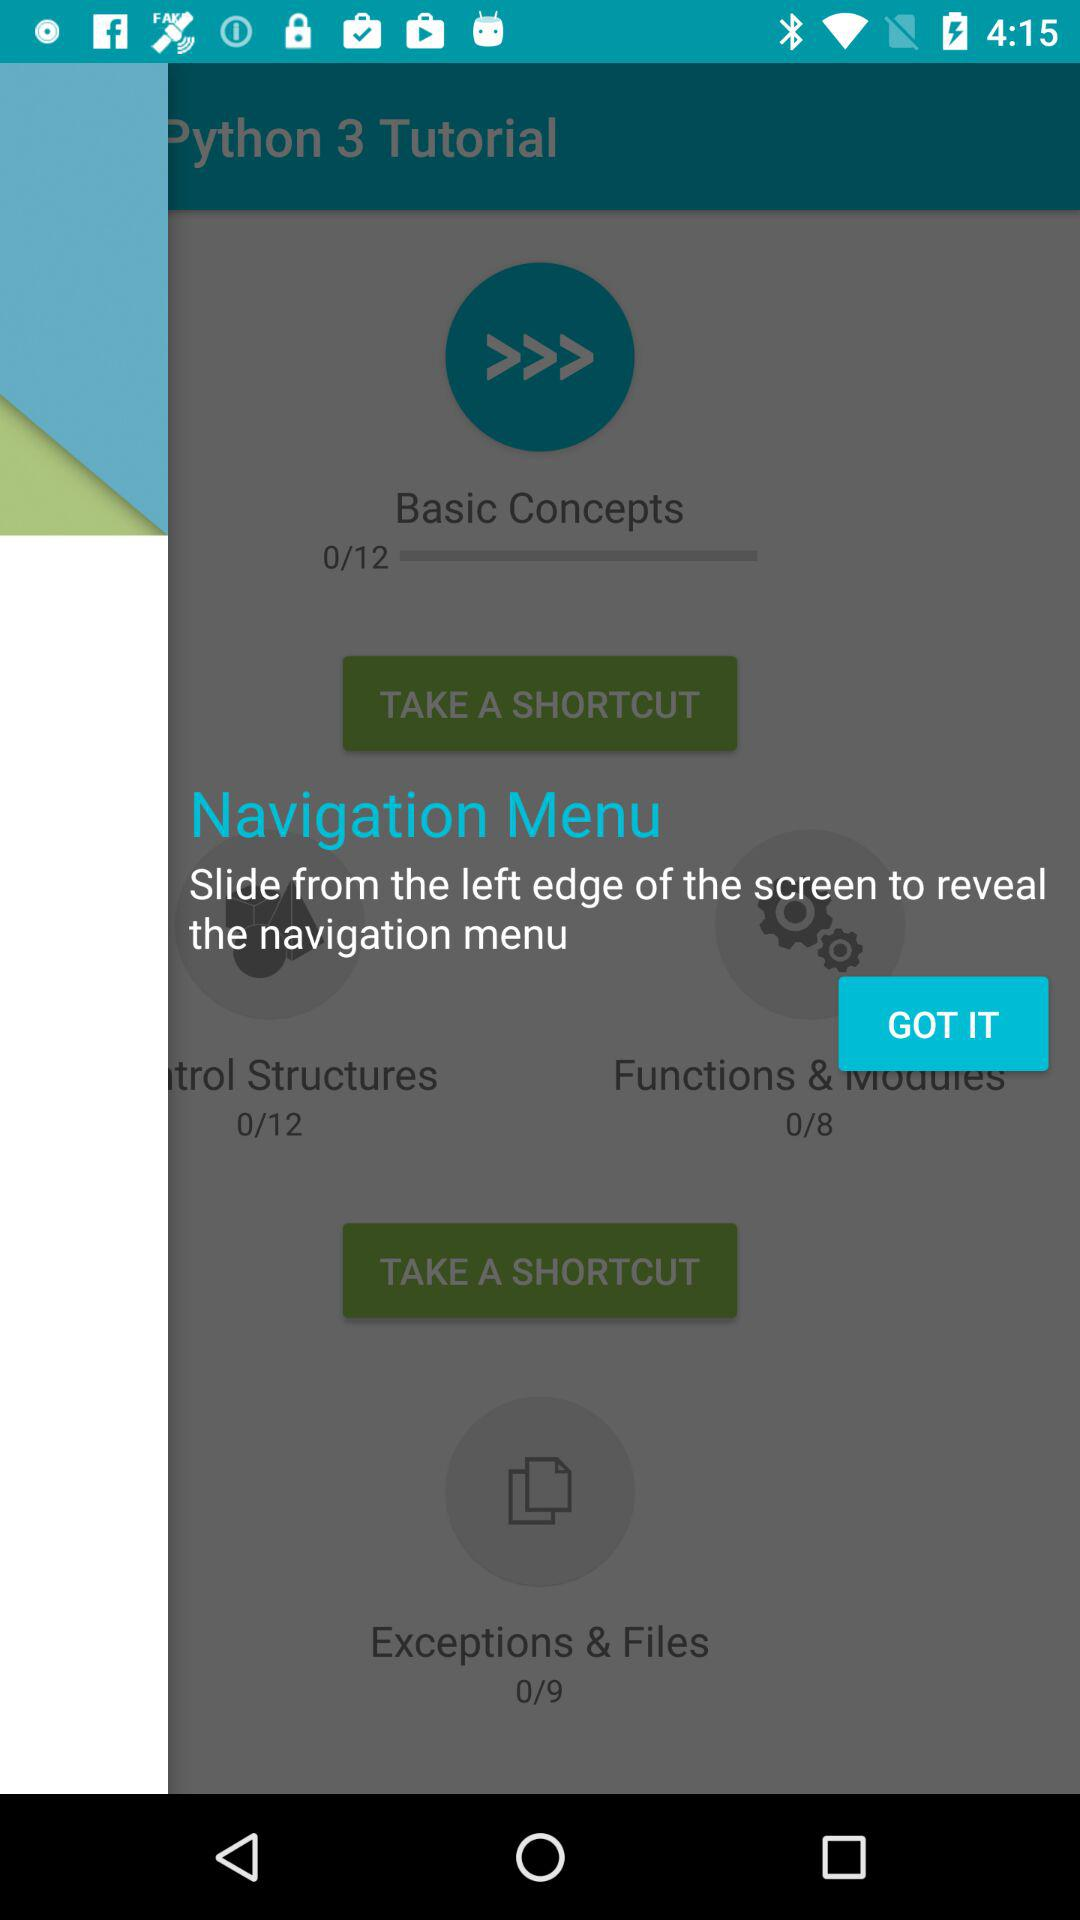From where should the screen be slid to reveal the navigation menu? The screen should be slid from the left edge of the screen to reveal the navigation menu. 